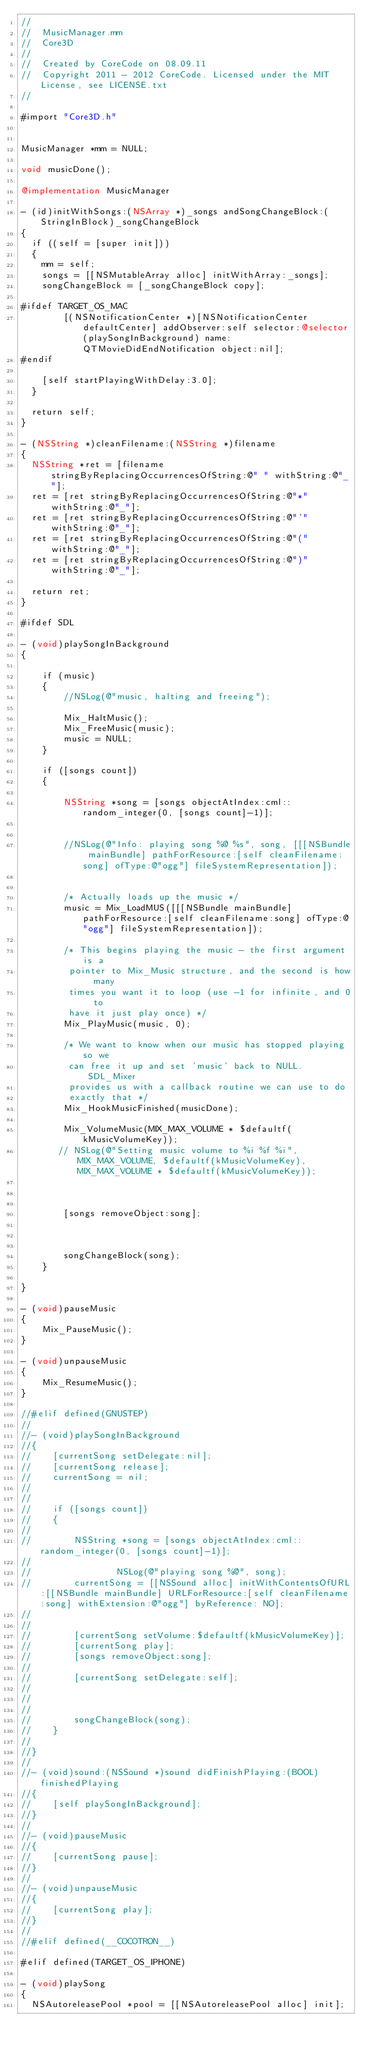Convert code to text. <code><loc_0><loc_0><loc_500><loc_500><_ObjectiveC_>//
//  MusicManager.mm
//  Core3D
//
//  Created by CoreCode on 08.09.11
//  Copyright 2011 - 2012 CoreCode. Licensed under the MIT License, see LICENSE.txt
//

#import "Core3D.h"


MusicManager *mm = NULL;

void musicDone();

@implementation MusicManager

- (id)initWithSongs:(NSArray *)_songs andSongChangeBlock:(StringInBlock)_songChangeBlock
{
	if ((self = [super init]))
	{
		mm = self;
		songs = [[NSMutableArray alloc] initWithArray:_songs];
		songChangeBlock = [_songChangeBlock copy];

#ifdef TARGET_OS_MAC
        [(NSNotificationCenter *)[NSNotificationCenter defaultCenter] addObserver:self selector:@selector(playSongInBackground) name:QTMovieDidEndNotification object:nil];
#endif

		[self startPlayingWithDelay:3.0];
	}

	return self;
}

- (NSString *)cleanFilename:(NSString *)filename
{
	NSString *ret = [filename stringByReplacingOccurrencesOfString:@" " withString:@"_"];
	ret = [ret stringByReplacingOccurrencesOfString:@"*" withString:@"_"];
	ret = [ret stringByReplacingOccurrencesOfString:@"'" withString:@"_"];
	ret = [ret stringByReplacingOccurrencesOfString:@"(" withString:@"_"];
	ret = [ret stringByReplacingOccurrencesOfString:@")" withString:@"_"];

	return ret;
}

#ifdef SDL

- (void)playSongInBackground
{

    if (music)
    {
        //NSLog(@"music, halting and freeing");

        Mix_HaltMusic();
        Mix_FreeMusic(music);
        music = NULL;
    }

    if ([songs count])
    {

        NSString *song = [songs objectAtIndex:cml::random_integer(0, [songs count]-1)];


        //NSLog(@"Info: playing song %@ %s", song, [[[NSBundle mainBundle] pathForResource:[self cleanFilename:song] ofType:@"ogg"] fileSystemRepresentation]);


        /* Actually loads up the music */
        music = Mix_LoadMUS([[[NSBundle mainBundle] pathForResource:[self cleanFilename:song] ofType:@"ogg"] fileSystemRepresentation]);

        /* This begins playing the music - the first argument is a
         pointer to Mix_Music structure, and the second is how many
         times you want it to loop (use -1 for infinite, and 0 to
         have it just play once) */
        Mix_PlayMusic(music, 0);

        /* We want to know when our music has stopped playing so we
         can free it up and set 'music' back to NULL.  SDL_Mixer
         provides us with a callback routine we can use to do
         exactly that */
        Mix_HookMusicFinished(musicDone);

        Mix_VolumeMusic(MIX_MAX_VOLUME * $defaultf(kMusicVolumeKey));
       // NSLog(@"Setting music volume to %i %f %i", MIX_MAX_VOLUME, $defaultf(kMusicVolumeKey), MIX_MAX_VOLUME * $defaultf(kMusicVolumeKey));



        [songs removeObject:song];



        songChangeBlock(song);
    }

}

- (void)pauseMusic
{
    Mix_PauseMusic();
}

- (void)unpauseMusic
{
    Mix_ResumeMusic();
}

//#elif defined(GNUSTEP)
//
//- (void)playSongInBackground
//{
//    [currentSong setDelegate:nil];
//    [currentSong release];
//    currentSong = nil;
//
//
//    if ([songs count])
//    {
//
//        NSString *song = [songs objectAtIndex:cml::random_integer(0, [songs count]-1)];
//
//                NSLog(@"playing song %@", song);
//        currentSong = [[NSSound alloc] initWithContentsOfURL:[[NSBundle mainBundle] URLForResource:[self cleanFilename:song] withExtension:@"ogg"] byReference: NO];
//
//
//        [currentSong setVolume:$defaultf(kMusicVolumeKey)];
//        [currentSong play];
//        [songs removeObject:song];
//
//        [currentSong setDelegate:self];
//
//
//
//        songChangeBlock(song);
//    }
//
//}
//
//- (void)sound:(NSSound *)sound didFinishPlaying:(BOOL)finishedPlaying
//{
//    [self playSongInBackground];
//}
//
//- (void)pauseMusic
//{
//    [currentSong pause];
//}
//
//- (void)unpauseMusic
//{
//    [currentSong play];
//}
//
//#elif defined(__COCOTRON__)

#elif defined(TARGET_OS_IPHONE)

- (void)playSong
{
	NSAutoreleasePool *pool = [[NSAutoreleasePool alloc] init];</code> 